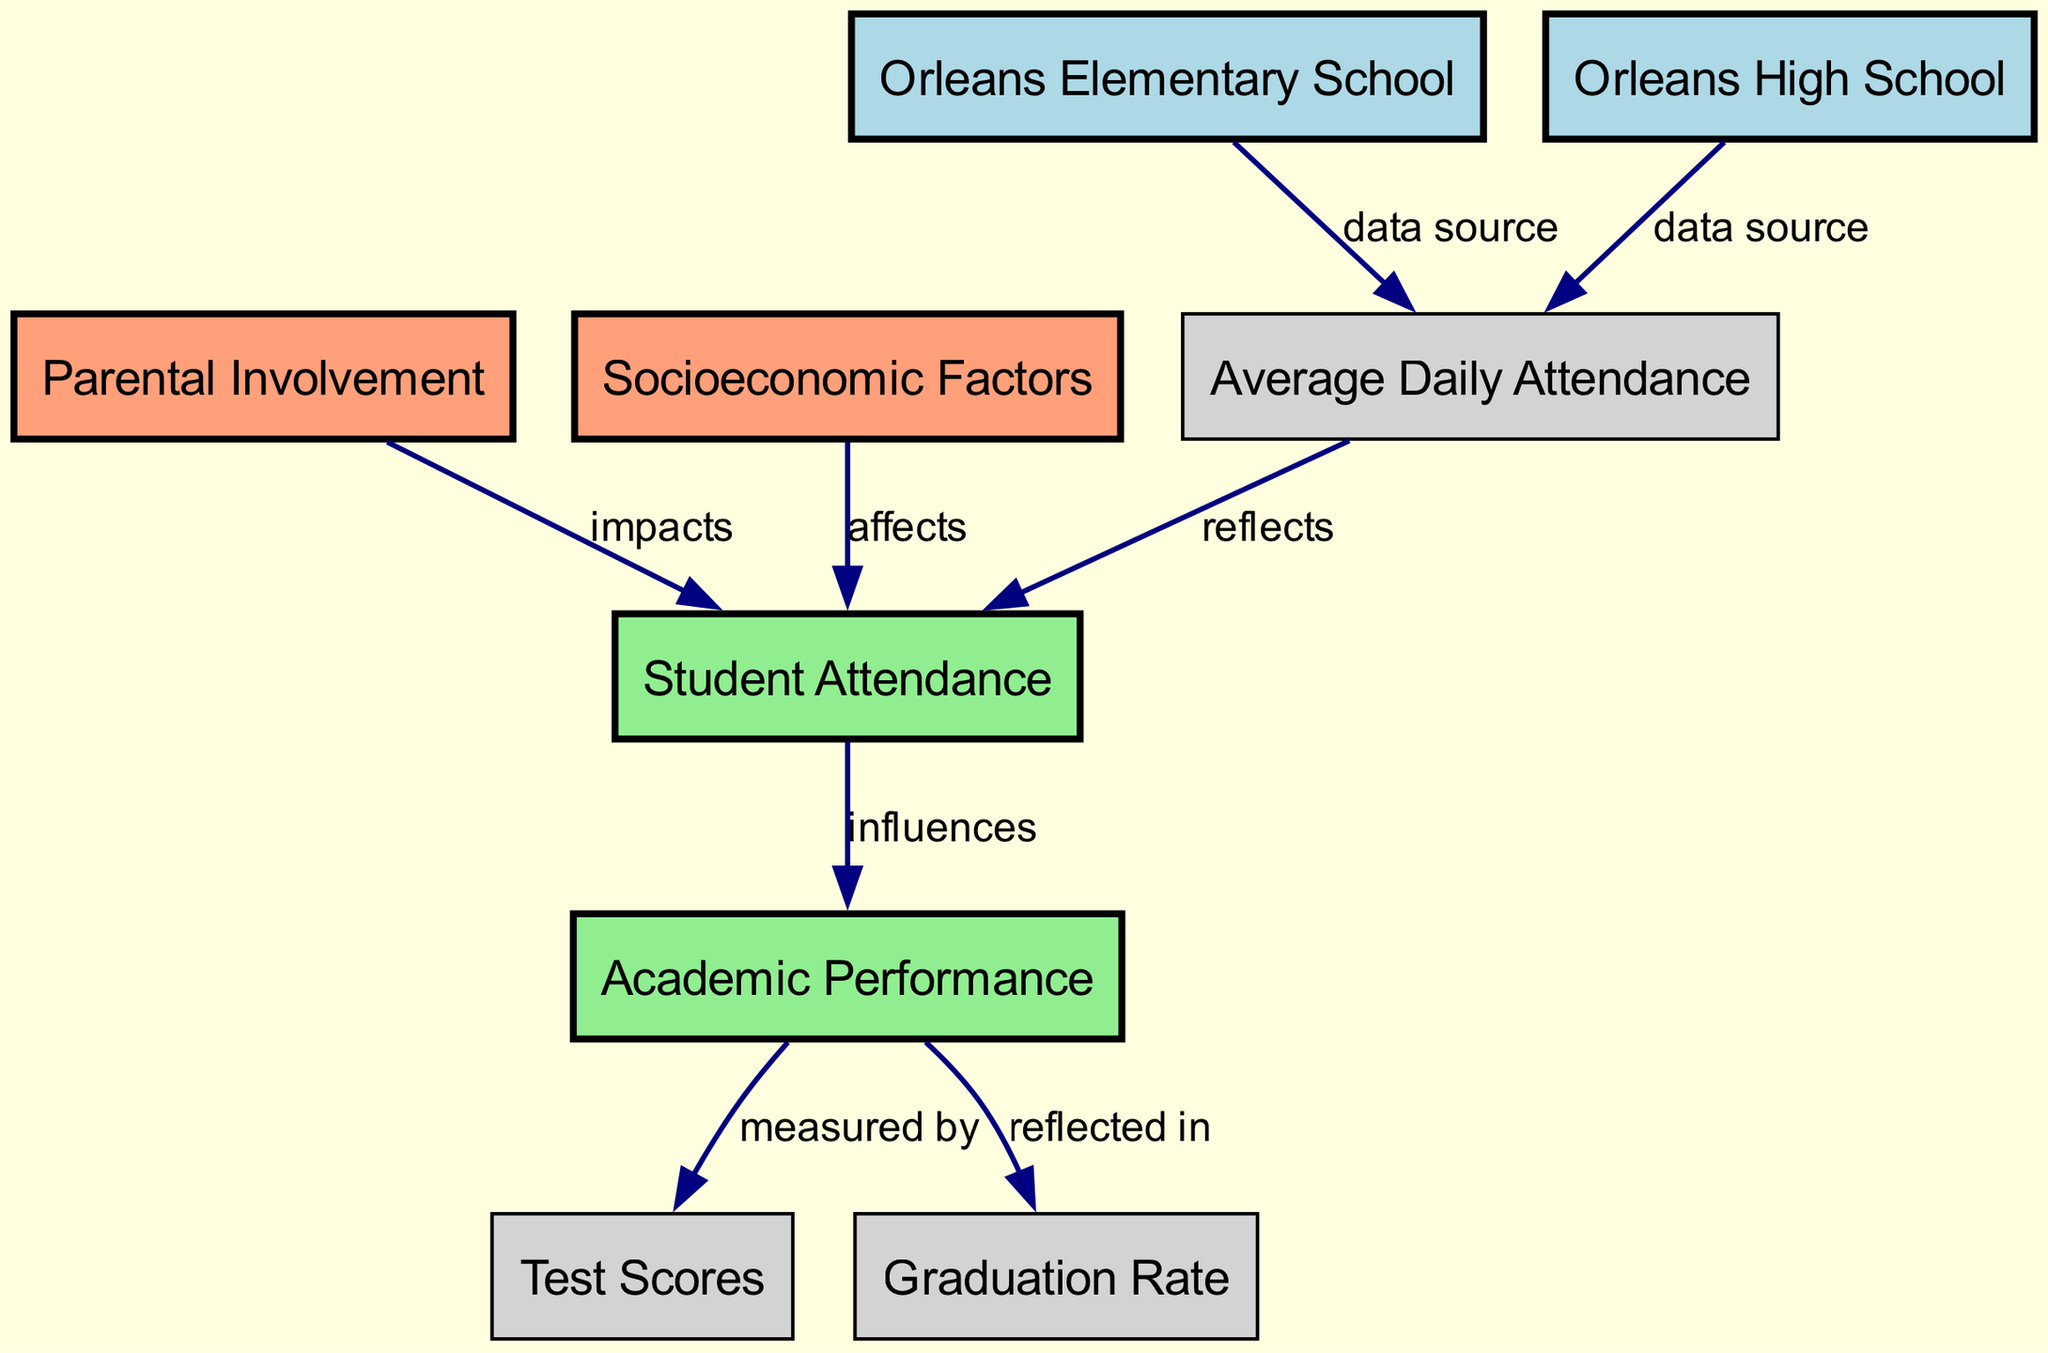What are the two schools represented in the diagram? The diagram includes two nodes labeled "Orleans Elementary School" and "Orleans High School."
Answer: Orleans Elementary School, Orleans High School How many external factors affect student attendance? The diagram shows two external factors: "Parental Involvement" and "Socioeconomic Factors."
Answer: 2 What is measured by academic performance? The diagram specifies that academic performance is measured by "Test Scores."
Answer: Test Scores Which concept influences academic performance? The diagram indicates that "Student Attendance" influences "Academic Performance."
Answer: Student Attendance What reflects the academic performance in terms of student outcomes? According to the diagram, academic performance is reflected in the "Graduation Rate."
Answer: Graduation Rate How does parental involvement relate to student attendance? The diagram states that "Parental Involvement" impacts "Student Attendance," showing a direct relationship.
Answer: Impacts What are the two data sources for average daily attendance? The sources for average daily attendance are "Orleans Elementary School" and "Orleans High School."
Answer: Orleans Elementary School, Orleans High School Which node is affected by socioeconomic factors? The diagram shows that "Student Attendance" is affected by "Socioeconomic Factors."
Answer: Student Attendance How many edges connect the main concepts in the diagram? There are three edges connecting the main concepts “Student Attendance” and “Academic Performance.”
Answer: 3 